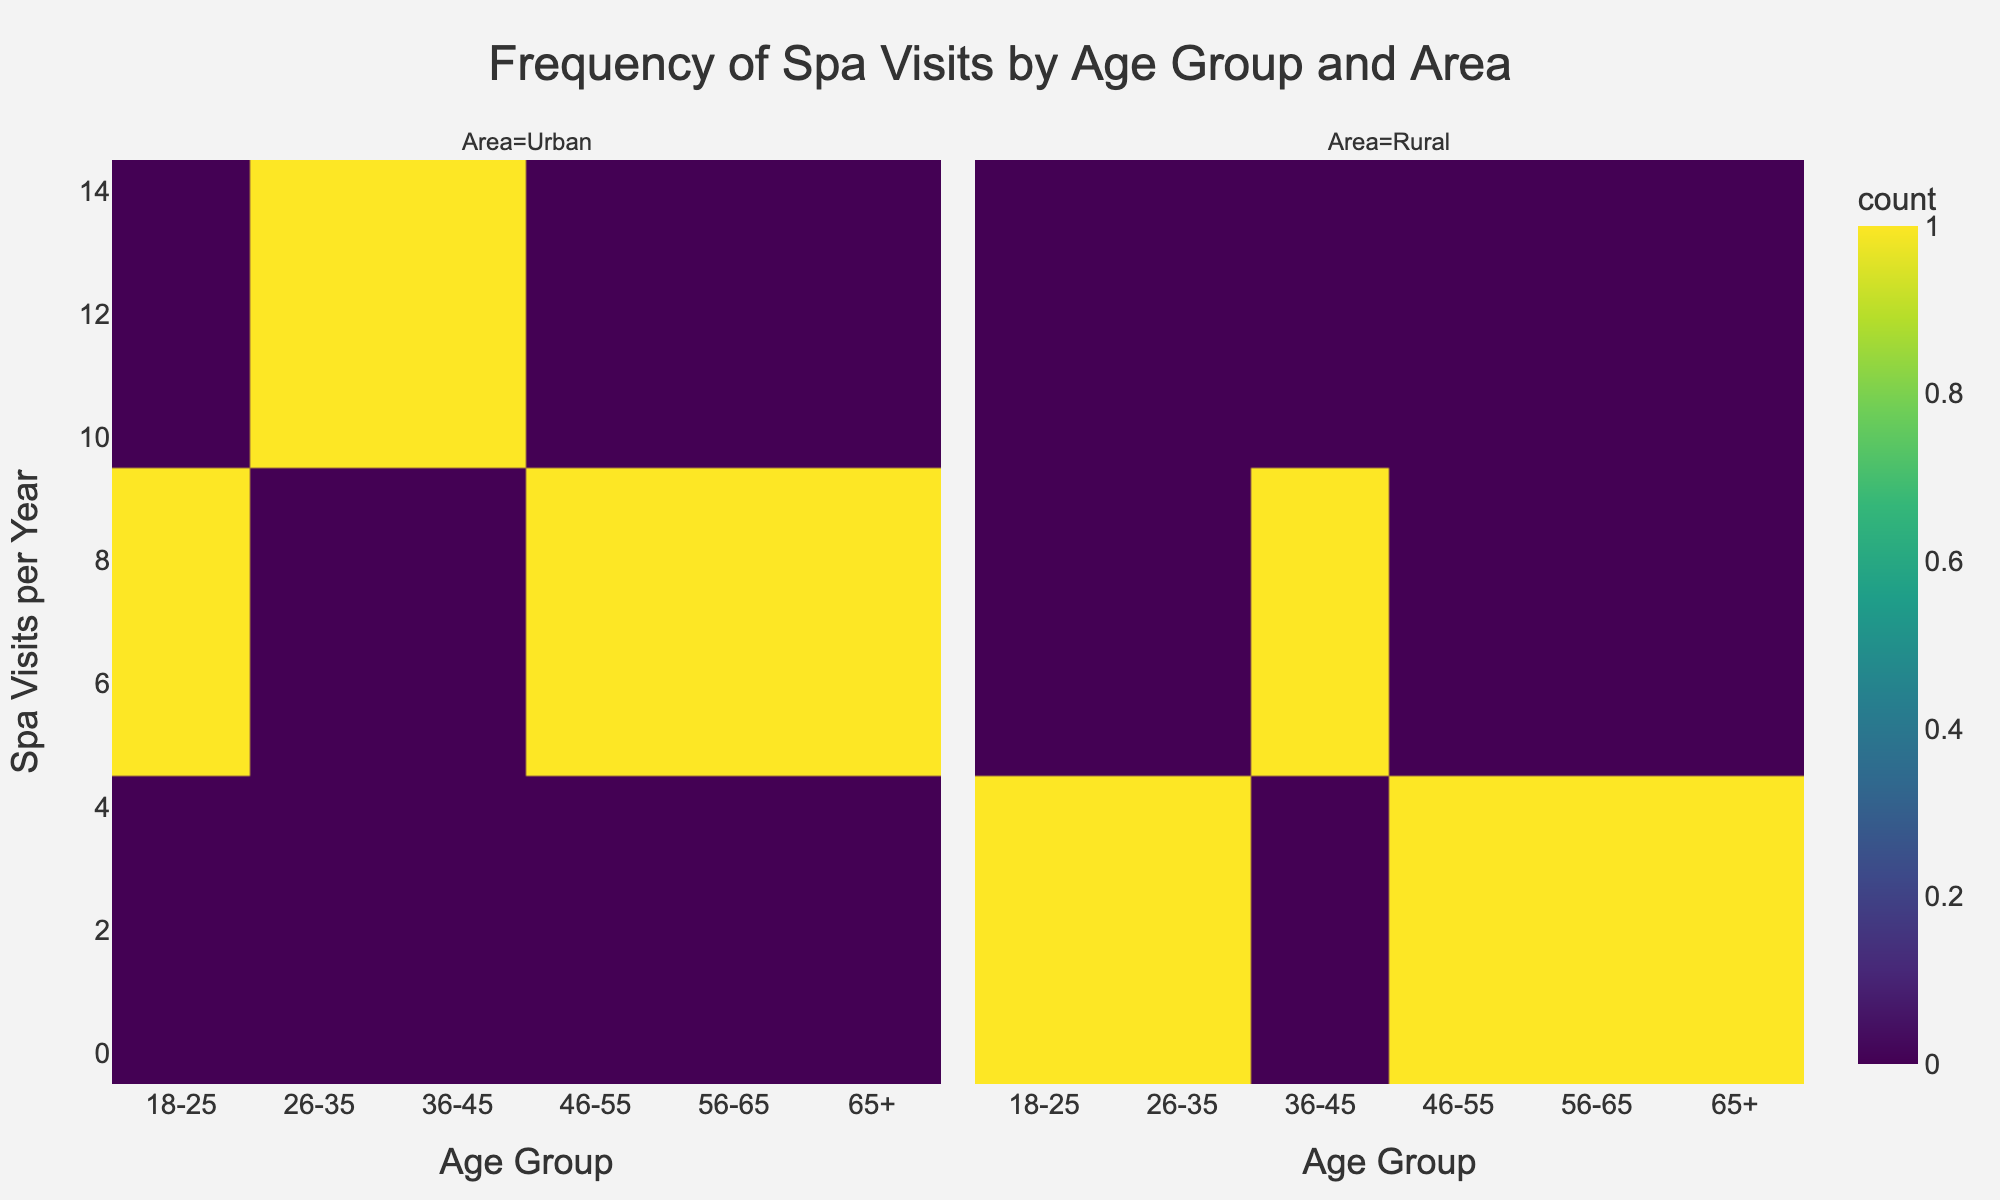What is the title of the plot? The title is usually placed at the top center of the plot. In this case, the title of the plot reads "Frequency of Spa Visits by Age Group and Area".
Answer: Frequency of Spa Visits by Age Group and Area How many age groups are depicted in the plot? The x-axis categorizes age groups, and counting the unique categories will give the answer. The plot shows the following age groups: "18-25", "26-35", "36-45", "46-55", "56-65", "65+", making a total of 6 age groups.
Answer: 6 Which area has the highest frequency of spa visits in the '36-45' age group? The '36-45' age group section of the plot can be examined for both Urban and Rural areas. The color intensity indicates the frequency, with Urban showing a higher frequency (11) compared to Rural (5).
Answer: Urban In the '26-35' age group, what is the difference in the frequency of spa visits between urban and rural areas? For the '26-35' age group, the urban frequency is 10 and the rural frequency is 4. The difference is calculated by subtracting rural from urban: 10 - 4 = 6.
Answer: 6 What is the average frequency of spa visits in urban areas across all age groups? Summing up the frequencies in urban areas for all age groups (8 + 10 + 11 + 9 + 7 + 5 = 50) and dividing by the number of age groups (6) gives the average. The calculation is 50/6 = 8.33.
Answer: 8.33 Which age group has the lowest frequency of spa visits in rural areas? Examining the rural sections for frequency colors across all age groups indicates '65+' has the lowest frequency, which is 2.
Answer: 65+ How does the frequency of spa visits change with age in urban areas? Observing the trend from '18-25' to '65+', there is an initial increase in frequency till '36-45', followed by a steady decline. The sequence of frequencies is 8, 10, 11, 9, 7, 5.
Answer: Increases then decreases Is there any age group in rural areas with a frequency of spa visits greater than 5? Checking the rural section across all age groups shows that none of the frequencies exceed 5, as the highest value observed in rural sections is 5.
Answer: No What is the total frequency of spa visits for the '46-55' age group across both areas? Adding the frequencies from both areas ('46-55'): urban (9) and rural (4). The total is 9 + 4 = 13.
Answer: 13 